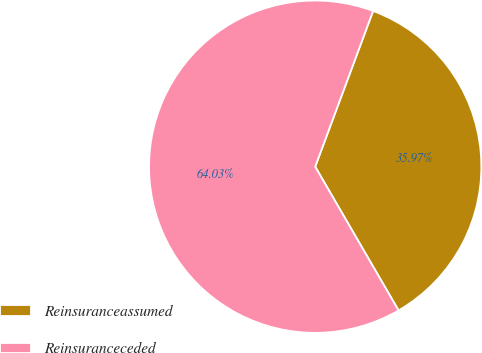Convert chart to OTSL. <chart><loc_0><loc_0><loc_500><loc_500><pie_chart><fcel>Reinsuranceassumed<fcel>Reinsuranceceded<nl><fcel>35.97%<fcel>64.03%<nl></chart> 